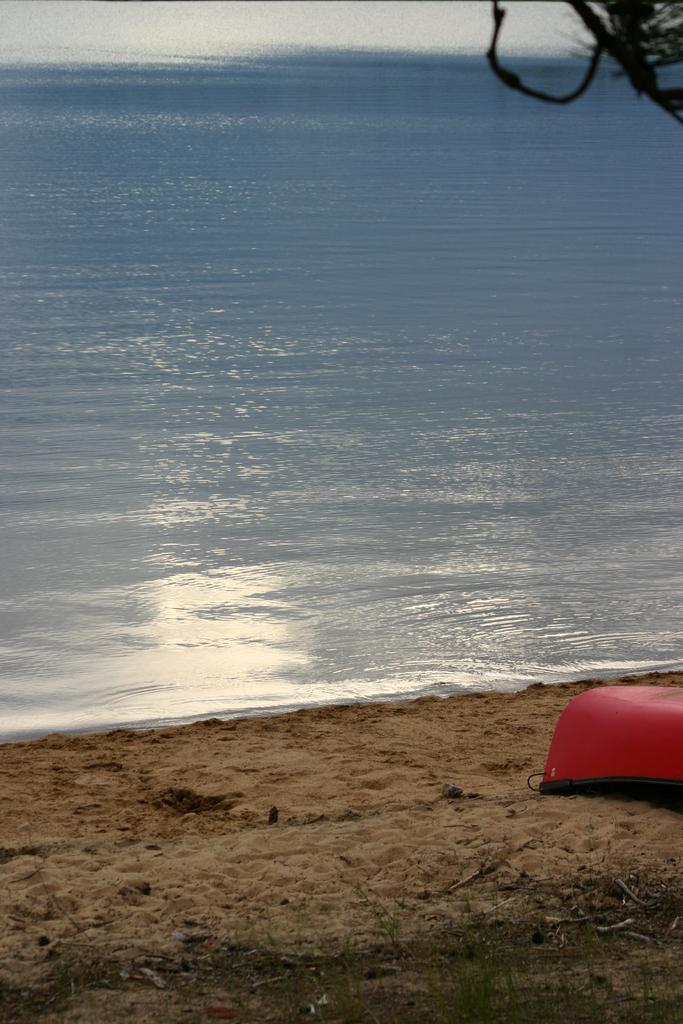Please provide a concise description of this image. In the image we can see sand, water and an object red in color. 